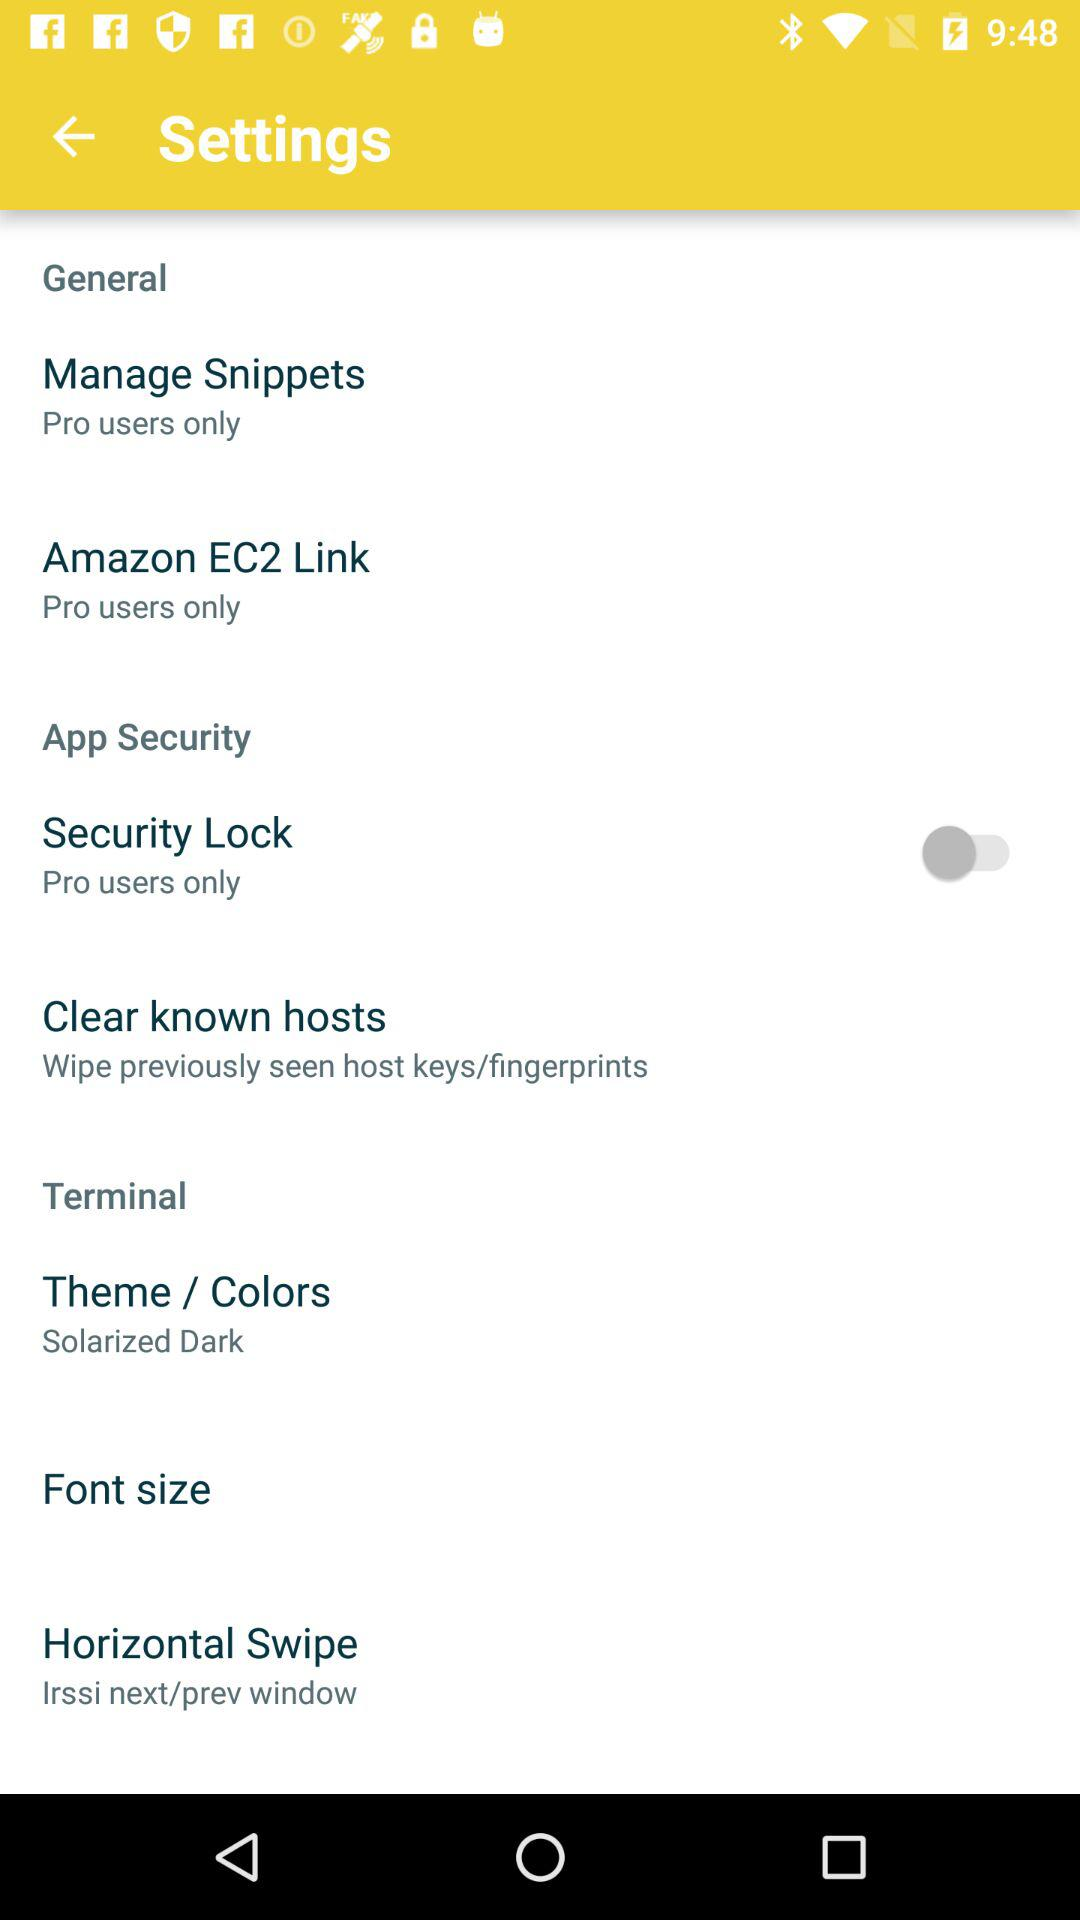What is the theme/color selected? The selected theme/color is solarized dark. 